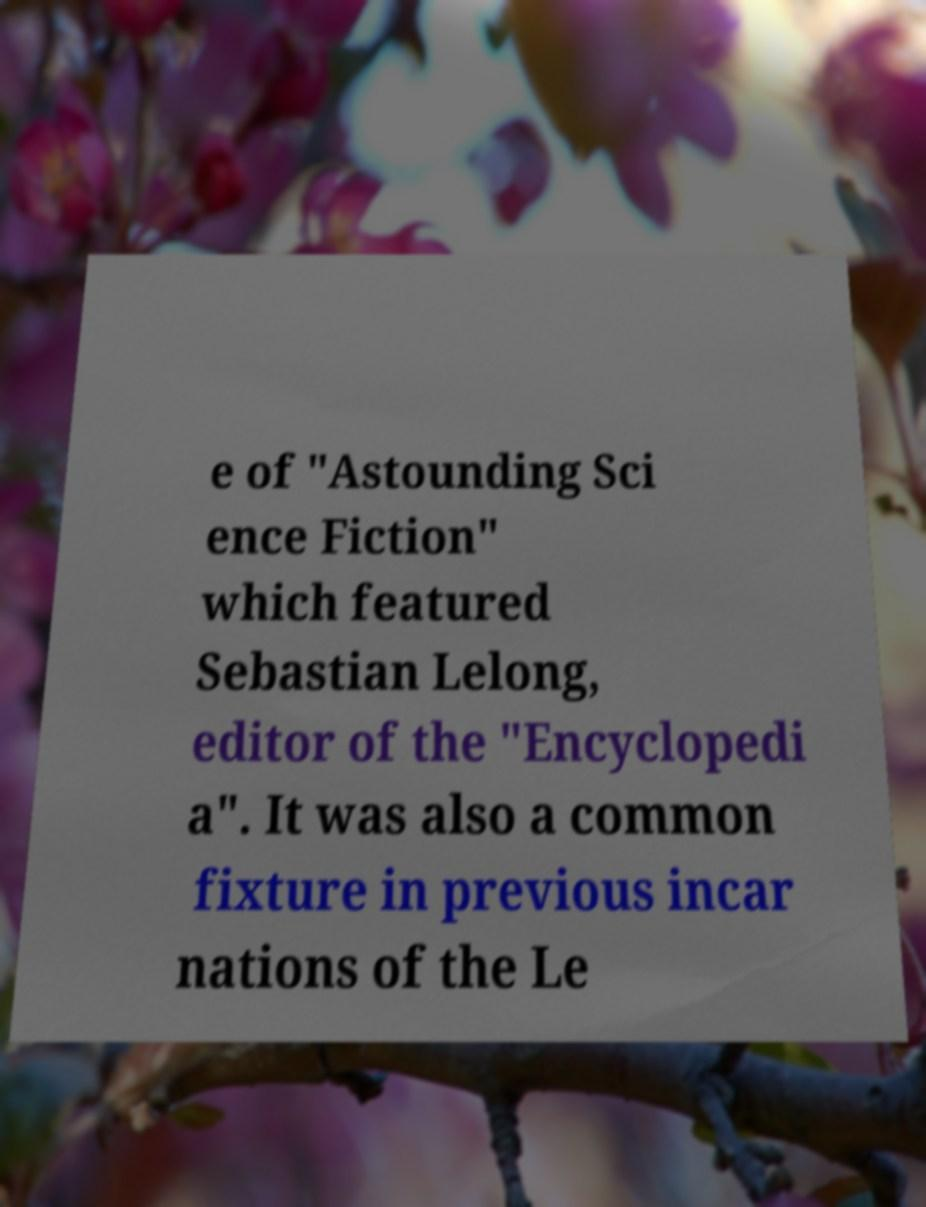Can you accurately transcribe the text from the provided image for me? e of "Astounding Sci ence Fiction" which featured Sebastian Lelong, editor of the "Encyclopedi a". It was also a common fixture in previous incar nations of the Le 